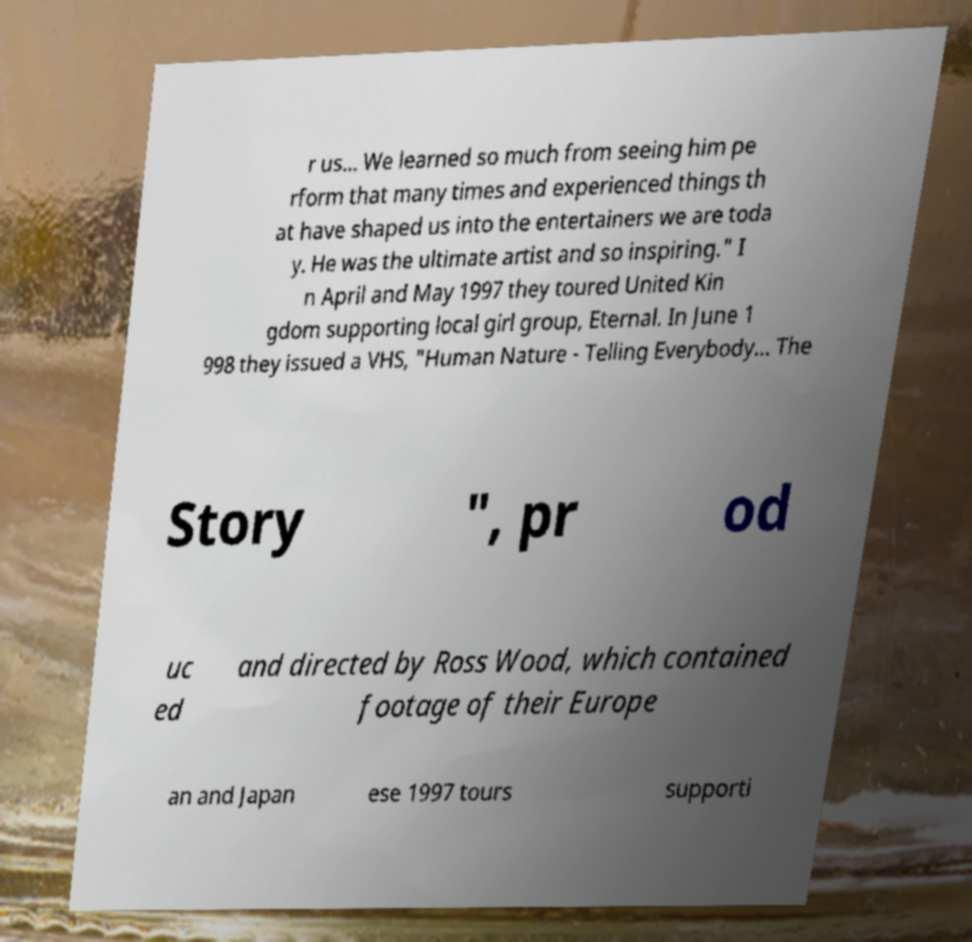Can you accurately transcribe the text from the provided image for me? r us... We learned so much from seeing him pe rform that many times and experienced things th at have shaped us into the entertainers we are toda y. He was the ultimate artist and so inspiring." I n April and May 1997 they toured United Kin gdom supporting local girl group, Eternal. In June 1 998 they issued a VHS, "Human Nature - Telling Everybody... The Story ", pr od uc ed and directed by Ross Wood, which contained footage of their Europe an and Japan ese 1997 tours supporti 